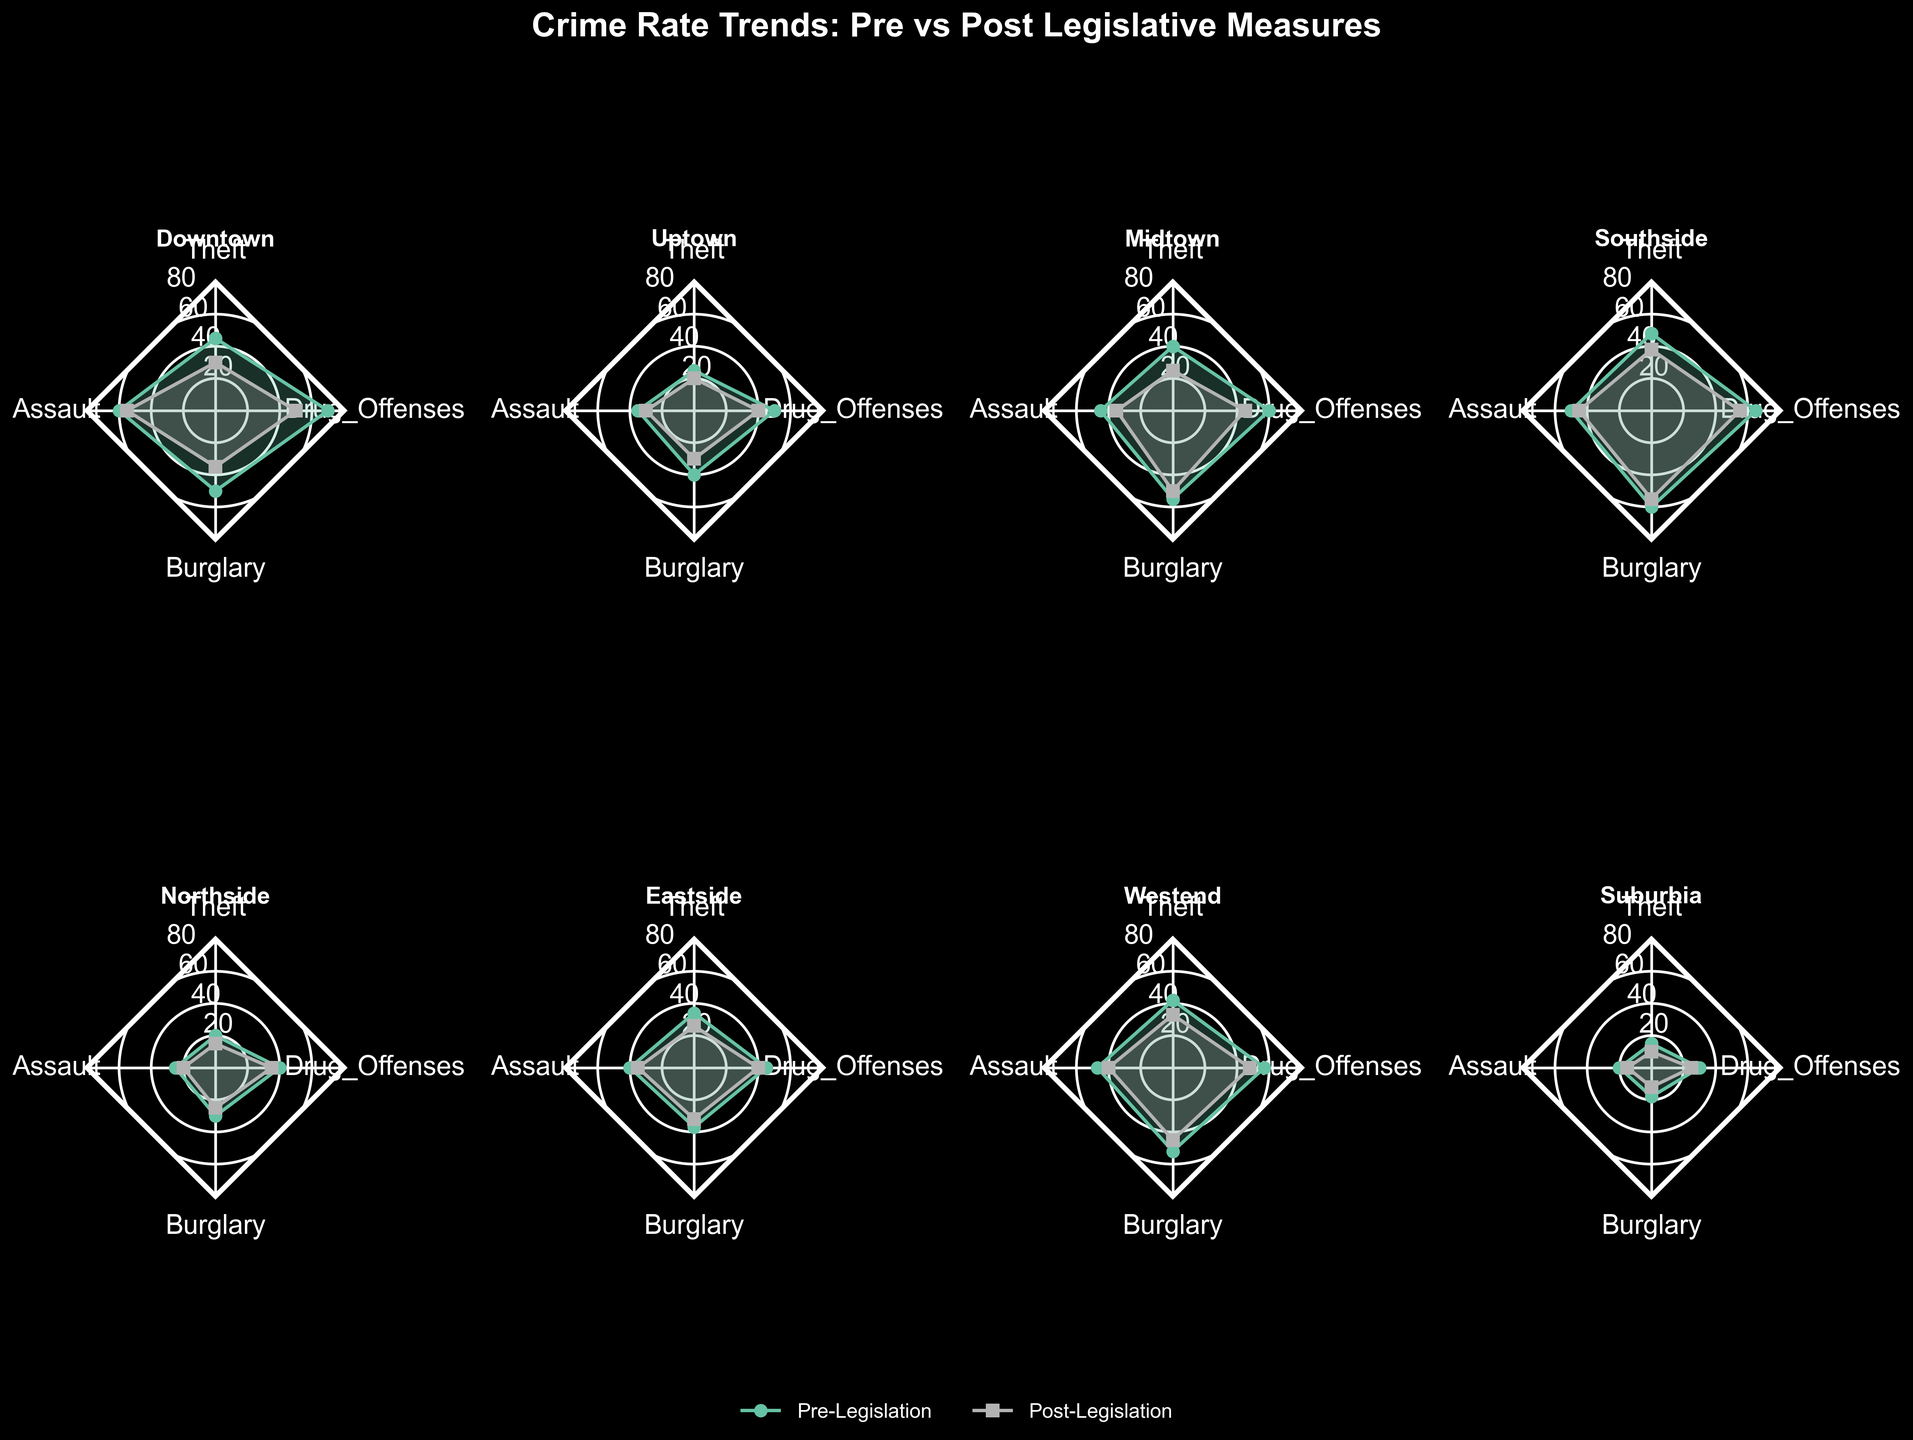Which neighborhood experienced the largest decrease in theft incidents after the legislation was passed? To find the neighborhood with the largest decrease in theft incidents, compare the difference between the Pre_Legislation_Theft and Post_Legislation_Theft values for each neighborhood and see which one is the largest. For instance, Downtown has a decrease of 45-30=15, which is larger than the decreases in other neighborhoods.
Answer: Downtown Which category saw the least change in crime rates for Uptown? Look for the smallest difference between Pre- and Post-Legislation crime rates in all categories for Uptown. The values for Uptown are: Theft (25, 20), Assault (35, 30), Burglary (40, 30), and Drug_Offenses (50, 40). The smallest change is in Assault, with a difference of 5.
Answer: Assault How did the crime rates for Drug Offenses change in Southside after the legislative measures were implemented? Check the Pre_Legislation_Drug_Offenses and Post_Legislation_Drug_Offenses values for Southside. They are 65 and 55, respectively, indicating a decrease of 10 incidents.
Answer: Decreased by 10 In the radar chart, which neighborhood shows a consistent decrease across all crime categories after the legislation? Compare the Pre- and Post-Legislation values for all categories in each neighborhood. Neighborhoods like Downtown, Uptown, and Suburbia show decreases in all categories.
Answer: Multiple (e.g., Downtown, Uptown, Suburbia) Which neighborhood had the highest pre-legislation assault rate? Look for the highest value in the Pre_Legislation_Assault column. The values are 60, 35, 45, 50, 25, 40, 47, and 20. The highest pre-legislation assault rate is in Downtown with 60 incidents.
Answer: Downtown Which neighborhood experienced the greatest reduction in burglary rates post-legislation? To determine this, calculate the difference between the Pre_Legislation_Burglary and Post_Legislation_Burglary values for each neighborhood. For example, Downtown's reduction is 50-35=15. Compare this with reductions in other neighborhoods to find the greatest reduction.
Answer: Downtown In which category did the Northside show the least improvement post-legislation? Compare the differences in Pre and Post values for all categories in Northside: Theft (5), Assault (5), Burglary (5), Drug_Offenses (5). Since all changes are the same, there is no single least improvement category.
Answer: All same For Eastside, which category showed the highest reduction in crime rates post-legislation? Compare the change in crime rates (Pre vs Post) for each category in Eastside: Theft (8), Assault (5), Burglary (5), Drug_Offenses (5). The highest reduction is in Theft with 8.
Answer: Theft Which neighborhood had the lowest pre-legislation drug offense rate? Look at the Pre_Legislation_Drug_Offenses column and find the lowest value. The values are 70, 50, 60, 65, 40, 45, 57, and 30. The lowest pre-legislation drug offense rate is in Suburbia with 30.
Answer: Suburbia 